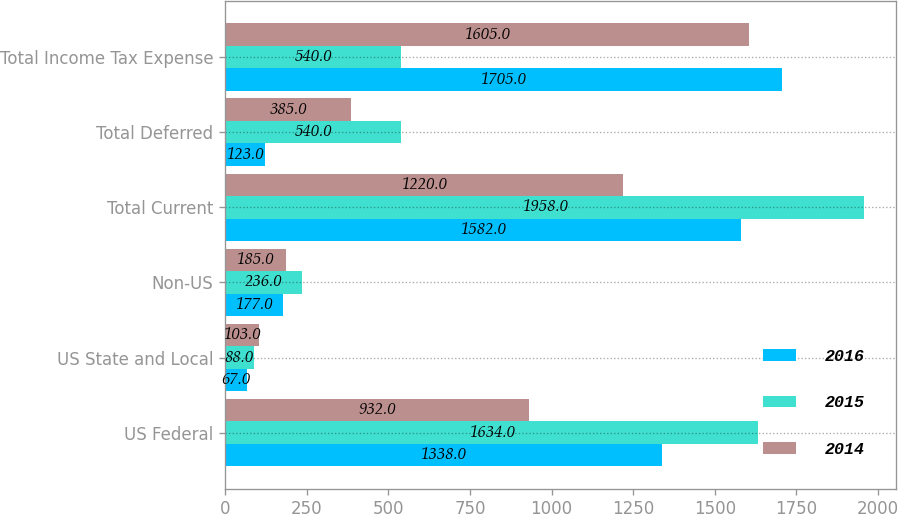Convert chart to OTSL. <chart><loc_0><loc_0><loc_500><loc_500><stacked_bar_chart><ecel><fcel>US Federal<fcel>US State and Local<fcel>Non-US<fcel>Total Current<fcel>Total Deferred<fcel>Total Income Tax Expense<nl><fcel>2016<fcel>1338<fcel>67<fcel>177<fcel>1582<fcel>123<fcel>1705<nl><fcel>2015<fcel>1634<fcel>88<fcel>236<fcel>1958<fcel>540<fcel>540<nl><fcel>2014<fcel>932<fcel>103<fcel>185<fcel>1220<fcel>385<fcel>1605<nl></chart> 